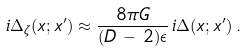<formula> <loc_0><loc_0><loc_500><loc_500>i \Delta _ { \zeta } ( x ; x ^ { \prime } ) \approx \frac { 8 \pi G } { ( D \, - \, 2 ) \epsilon } \, i \Delta ( x ; x ^ { \prime } ) \, .</formula> 